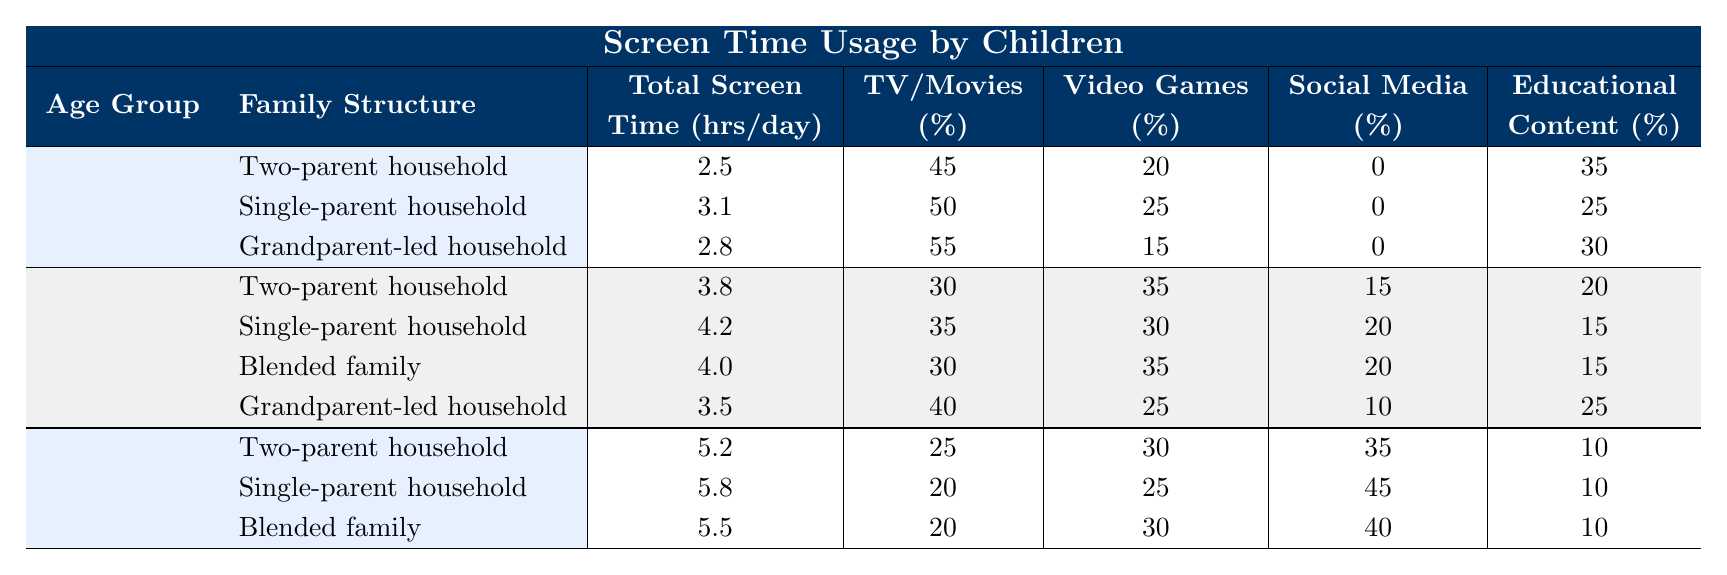What is the total screen time for children in single-parent households aged 6-12 years? The table shows that the total screen time for children in single-parent households aged 6-12 years is listed under the relevant row. The value is 4.2 hours/day.
Answer: 4.2 hours/day Which family structure has the highest percentage of screen time spent on TV/Movies for the 2-5 years age group? By looking at the table, the family structure with the highest percentage of screen time spent on TV/Movies in the 2-5 years age group is "Grandparent-led household" at 55%.
Answer: Grandparent-led household What is the difference in total screen time between children aged 2-5 years in single-parent and two-parent households? For single-parent households, the total screen time is 3.1 hours/day, and for two-parent households, it is 2.5 hours/day. The difference is 3.1 - 2.5 = 0.6 hours/day.
Answer: 0.6 hours/day What percentage of screen time for 13-17 years old in single-parent households is attributed to social media? The table shows that 45% of screen time for children aged 13-17 years in single-parent households is spent on social media.
Answer: 45% Which age group and family structure combination has the lowest total screen time? Scanning through the table, the combination with the lowest total screen time is "2-5 years" in a "Two-parent household" at 2.5 hours/day.
Answer: 2.5 hours/day What is the average total screen time for children aged 6-12 years across all family structures? The total screen time values for 6-12 years age group are 3.8, 4.2, 4.0, and 3.5 hours/day. To find the average, sum these values (3.8 + 4.2 + 4.0 + 3.5) = 15.5 hours, then divide by 4. Average = 15.5/4 = 3.875 hours/day.
Answer: 3.875 hours/day Is there a family structure where children aged 13-17 spend more than 5.5 hours per day on screen time? Checking the table, no family structure for children aged 13-17 exceeds a total screen time of 5.5 hours per day; the highest listed is 5.8 hours/day in single-parent households.
Answer: No How much total screen time do children in blended families aged 6-12 years spend compared to those in two-parent households of the same age? The total screen time for blended families is 4.0 hours/day and for two-parent households, it’s 3.8 hours/day. The difference between them is 4.0 - 3.8 = 0.2 hours/day, indicating blended families have more screen time.
Answer: 0.2 hours/day What percentage of total screen time in single-parent households aged 2-5 years is spent on video games? The table indicates that children in single-parent households aged 2-5 years spend 25% of their screen time on video games.
Answer: 25% Which family structure has the highest total screen time for children aged 2-5 years? Among the family structures listed for the 2-5 years age group, the single-parent household has the highest total screen time at 3.1 hours/day.
Answer: Single-parent household 